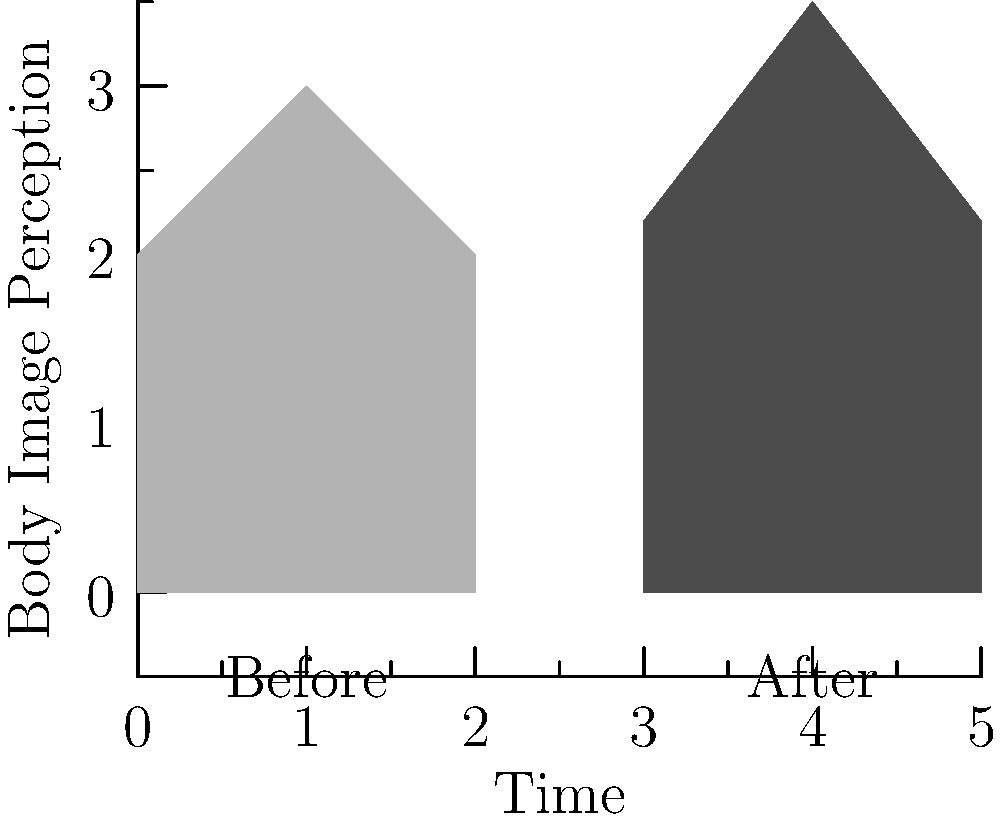Analyze the before-and-after silhouettes depicted in the graph. How might social media influencers contribute to the shift in body image perception among teenagers, and what potential long-term consequences could this have on their psychological well-being? Discuss the ethical implications for media studies professionals in addressing this issue. 1. Observe the silhouettes: The "After" silhouette is noticeably slimmer and taller than the "Before" silhouette.

2. Influencer impact: Social media influencers often promote unrealistic body standards through carefully curated content, filters, and editing techniques.

3. Teenage susceptibility: Adolescents are particularly vulnerable to social comparison and peer influence, making them more likely to internalize these idealized body images.

4. Shift in perception: The graph illustrates a potential shift towards a thinner, taller ideal body type, likely influenced by exposure to social media content.

5. Psychological consequences: This shift can lead to:
   a) Body dissatisfaction
   b) Low self-esteem
   c) Eating disorders
   d) Anxiety and depression

6. Long-term effects: Prolonged exposure to unrealistic standards can result in:
   a) Chronic mental health issues
   b) Distorted self-image
   c) Difficulty forming healthy relationships

7. Ethical implications for media professionals:
   a) Responsibility to educate about media literacy
   b) Need to promote diverse and realistic body representations
   c) Obligation to advocate for ethical social media practices
   d) Importance of conducting and disseminating research on media effects

8. Potential interventions:
   a) Developing media literacy programs
   b) Encouraging critical thinking about online content
   c) Promoting body-positive influencers and campaigns
   d) Advocating for transparent advertising practices on social media platforms
Answer: Social media influencers contribute to unrealistic body ideals, potentially causing long-term psychological harm to teenagers. Media professionals must address this through education, advocacy, and promoting diverse body representations. 